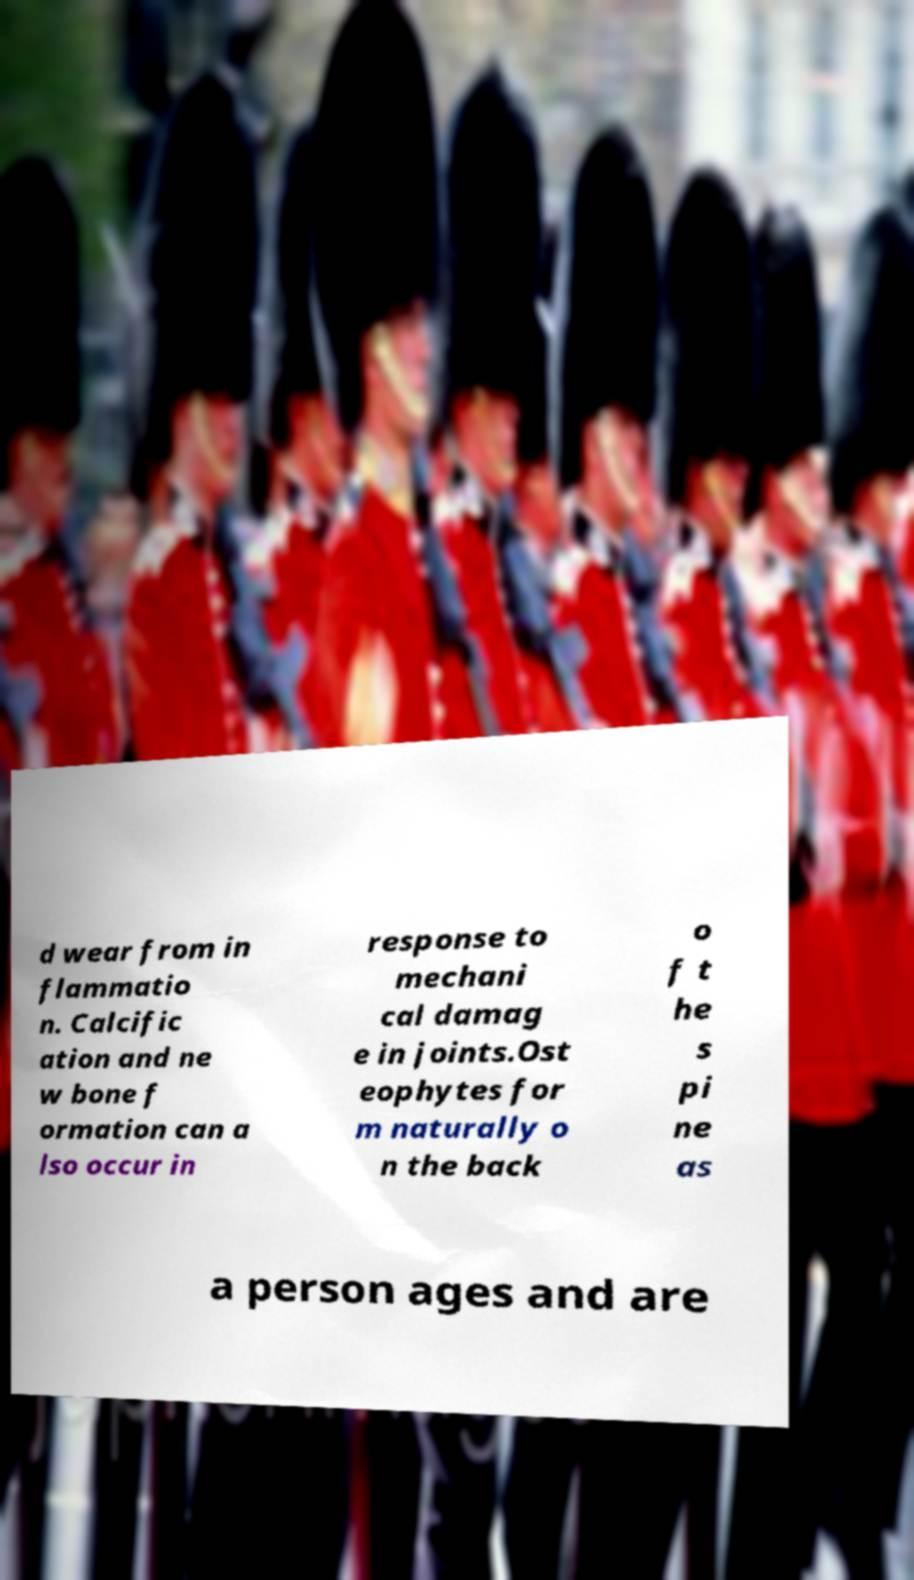There's text embedded in this image that I need extracted. Can you transcribe it verbatim? d wear from in flammatio n. Calcific ation and ne w bone f ormation can a lso occur in response to mechani cal damag e in joints.Ost eophytes for m naturally o n the back o f t he s pi ne as a person ages and are 